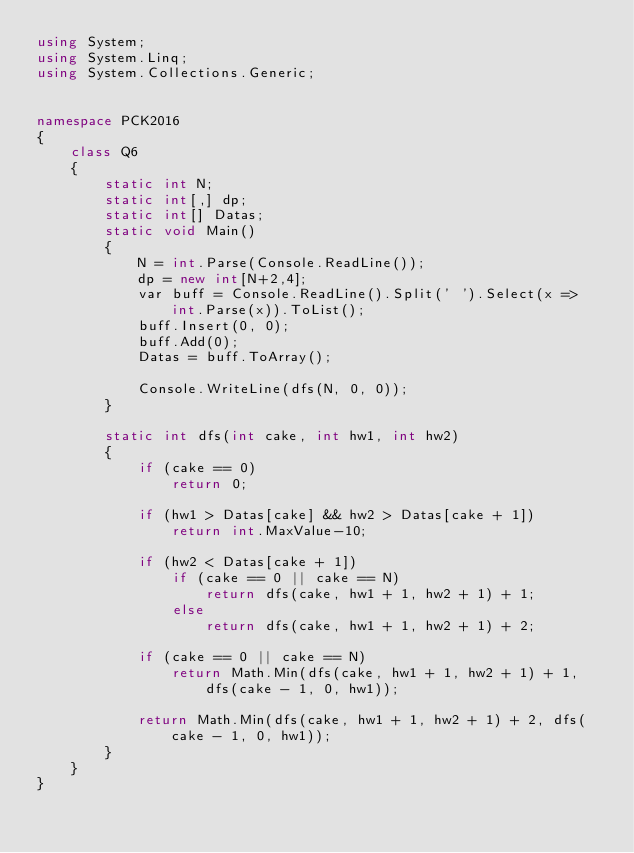<code> <loc_0><loc_0><loc_500><loc_500><_C#_>using System;
using System.Linq;
using System.Collections.Generic;


namespace PCK2016
{
    class Q6
    {
        static int N;
        static int[,] dp;
        static int[] Datas;
        static void Main()
        {
            N = int.Parse(Console.ReadLine());
            dp = new int[N+2,4];
            var buff = Console.ReadLine().Split(' ').Select(x => int.Parse(x)).ToList();
            buff.Insert(0, 0);
            buff.Add(0);
            Datas = buff.ToArray();

            Console.WriteLine(dfs(N, 0, 0));
        }

        static int dfs(int cake, int hw1, int hw2)
        {
            if (cake == 0)
                return 0;

            if (hw1 > Datas[cake] && hw2 > Datas[cake + 1])
                return int.MaxValue-10;

            if (hw2 < Datas[cake + 1])
                if (cake == 0 || cake == N)
                    return dfs(cake, hw1 + 1, hw2 + 1) + 1;
                else
                    return dfs(cake, hw1 + 1, hw2 + 1) + 2;

            if (cake == 0 || cake == N)
                return Math.Min(dfs(cake, hw1 + 1, hw2 + 1) + 1, dfs(cake - 1, 0, hw1));

            return Math.Min(dfs(cake, hw1 + 1, hw2 + 1) + 2, dfs(cake - 1, 0, hw1));
        }
    }
}</code> 